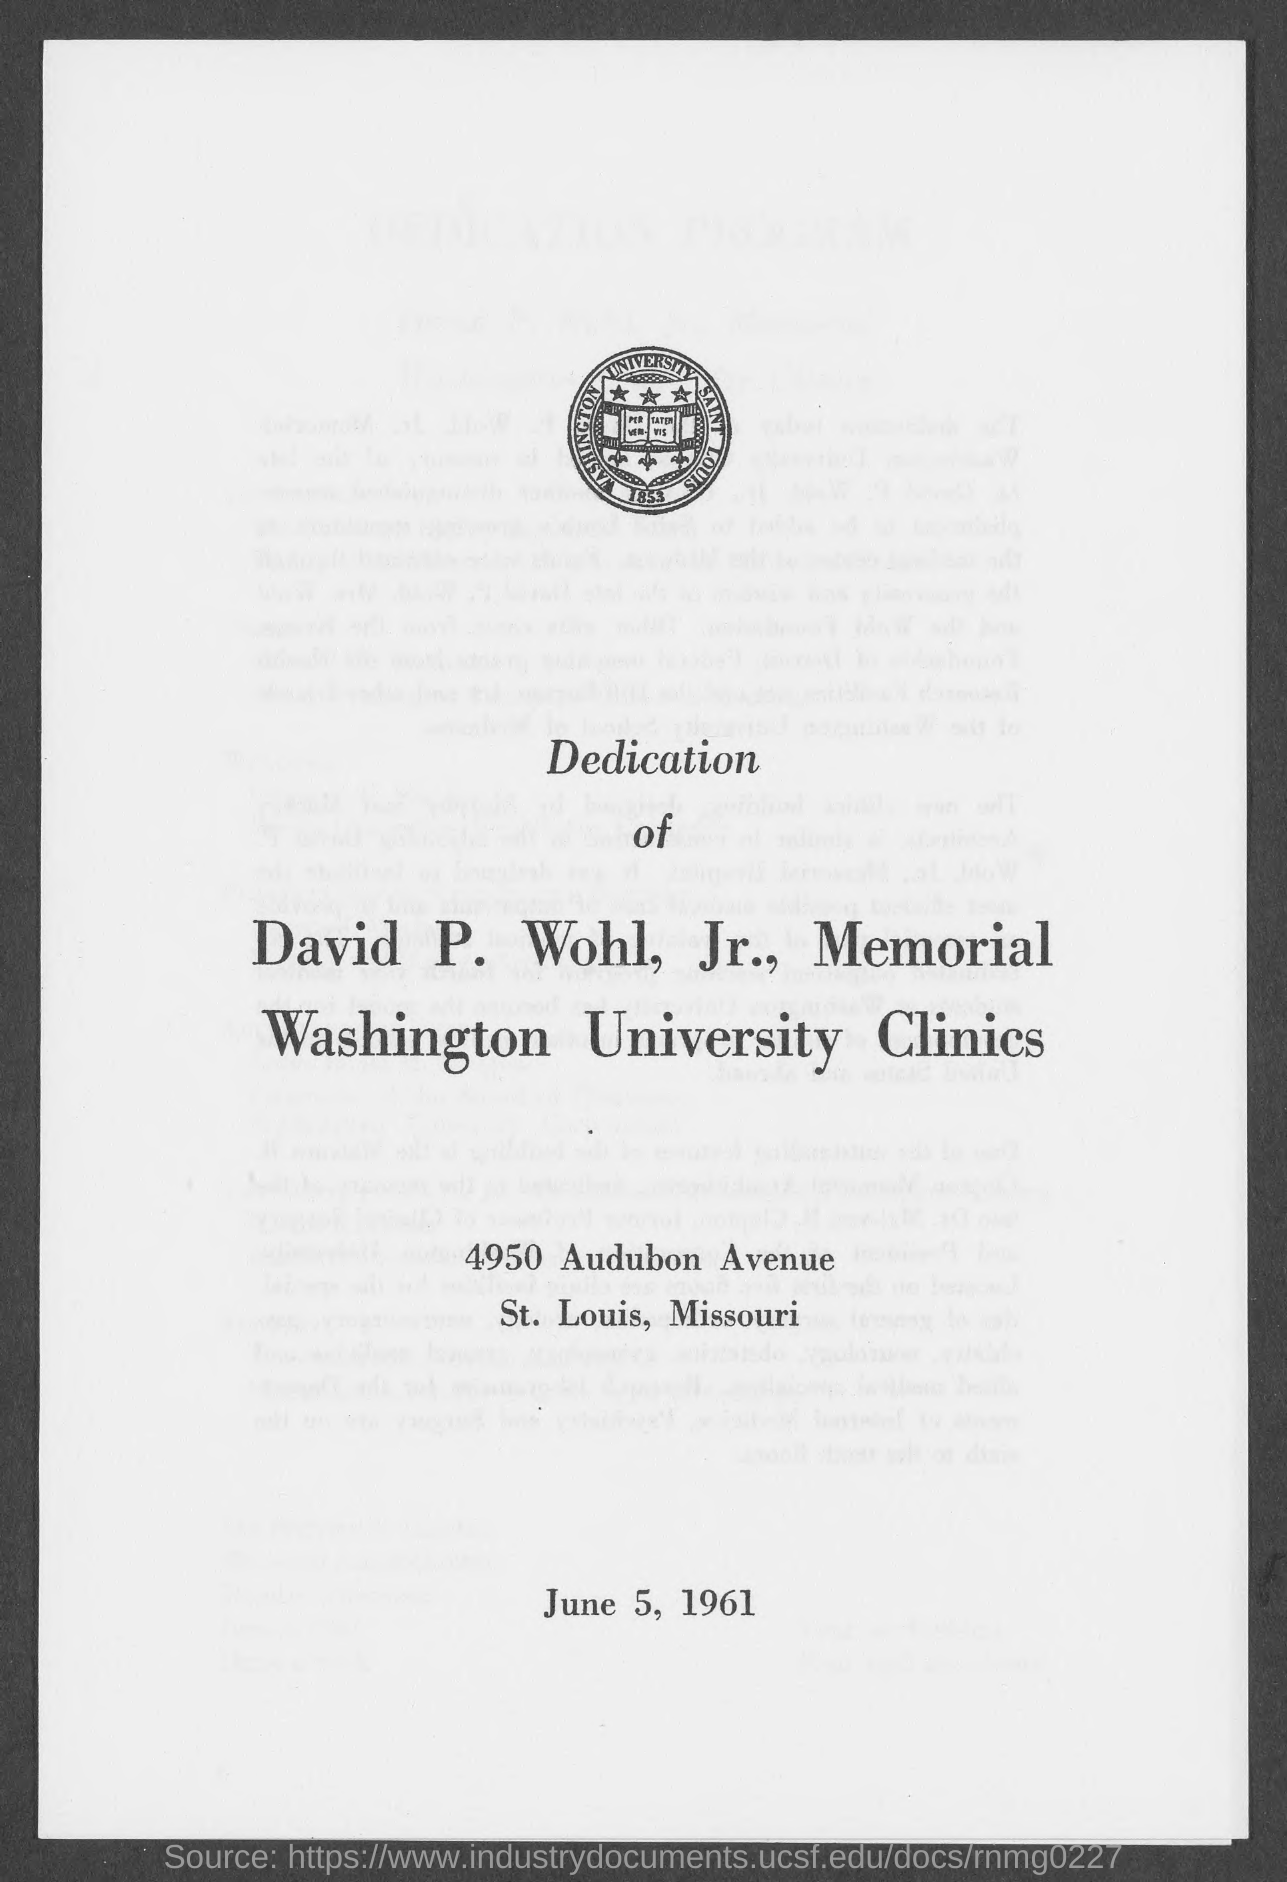Specify some key components in this picture. The copy was printed on June 5, 1961. The year 1853 is depicted in the logo. 